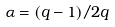Convert formula to latex. <formula><loc_0><loc_0><loc_500><loc_500>\alpha = ( q - 1 ) / 2 q</formula> 